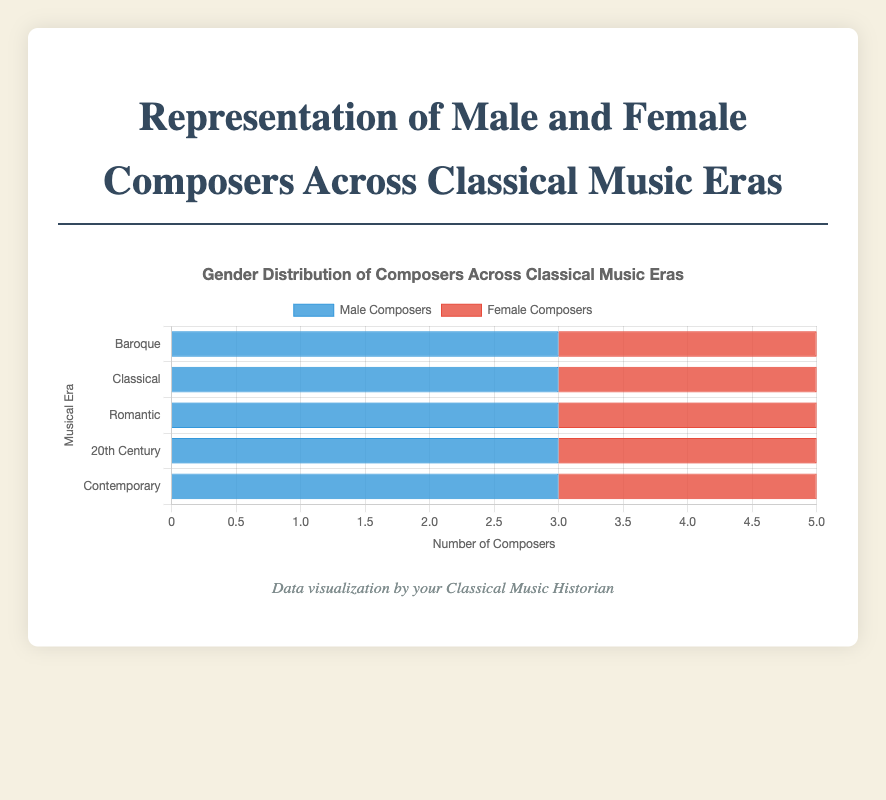Which era has the highest number of composed work by females? The Contemporary era has the highest number of female composers (3 colors of red bars). To answer this question, one must look at all the red bars representing female composers and identify which era has the longest red bar.
Answer: Contemporary Which era has the same number of male and female composers? The Classical era has an equal representation of male and female composers. One can deduce this by comparing the length of the blue and red bars for all the eras and finding which one is equal.
Answer: Classical In which era is the difference between male and female composers the largest? To find the era with the largest disparity, calculate the difference between the lengths of the blue and red bars across all eras. The Baroque era has the most significant difference (5 males and 0 females).
Answer: Baroque What is the total number of composers in the Romantic era? The total number of composers is found by adding the number of male composers (3) with the number of female composers (2) in the Romantic era.
Answer: 5 What is the average number of male composers across all eras? Sum the number of male composers in each era (5 + 3 + 3 + 3 + 3 = 17) and divide by the number of eras (5). The operation gives the average as 17/5 = 3.4.
Answer: 3.4 Are there more male or female composers in the 20th century era? By comparing the lengths of the blue (3) and red (2) bars for the 20th Century era, it is clear the blue bar representing male composers is longer.
Answer: Male Which era has the smallest proportional representation of female composers? Assess the length of the red bars across all eras to find the smallest, which occurs in the Baroque era with a value of 0.
Answer: Baroque How does the number of female composers in the Contemporary era compare to other eras? The Contemporary era has the highest number of female composers (3) which surpasses other eras when comparing the lengths of the red bars across all eras.
Answer: It is the highest 